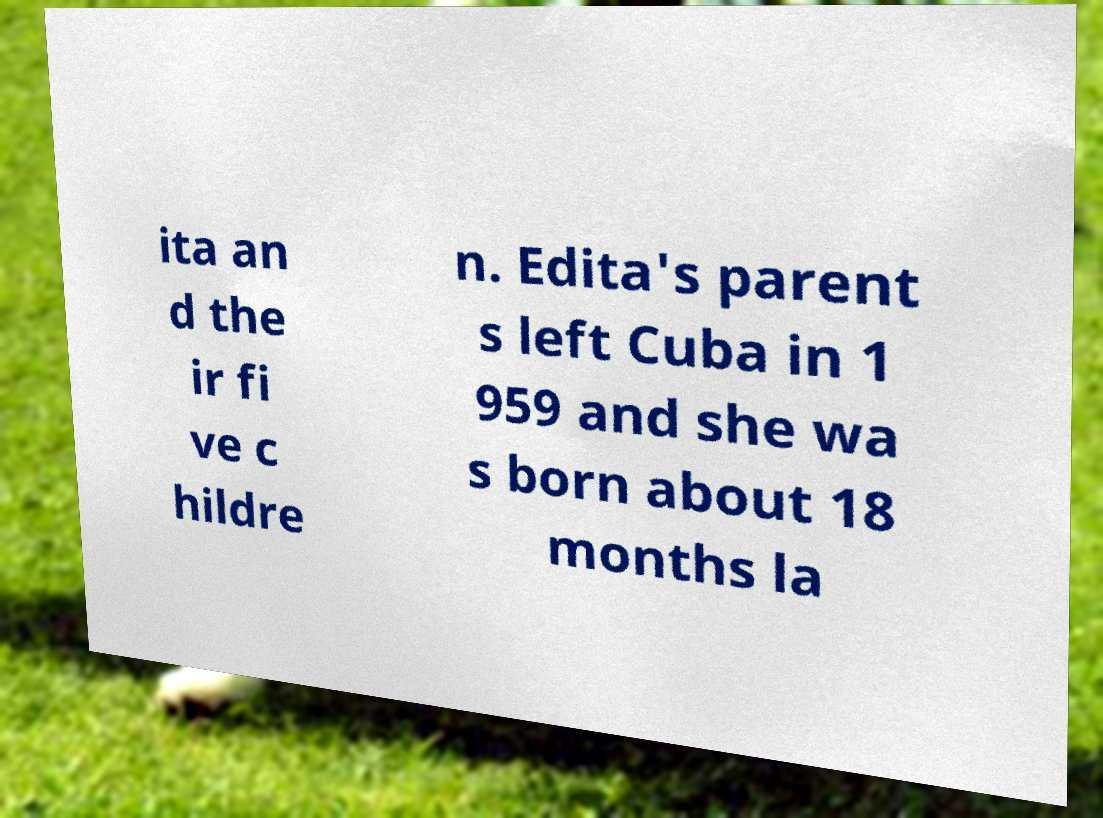Could you assist in decoding the text presented in this image and type it out clearly? ita an d the ir fi ve c hildre n. Edita's parent s left Cuba in 1 959 and she wa s born about 18 months la 